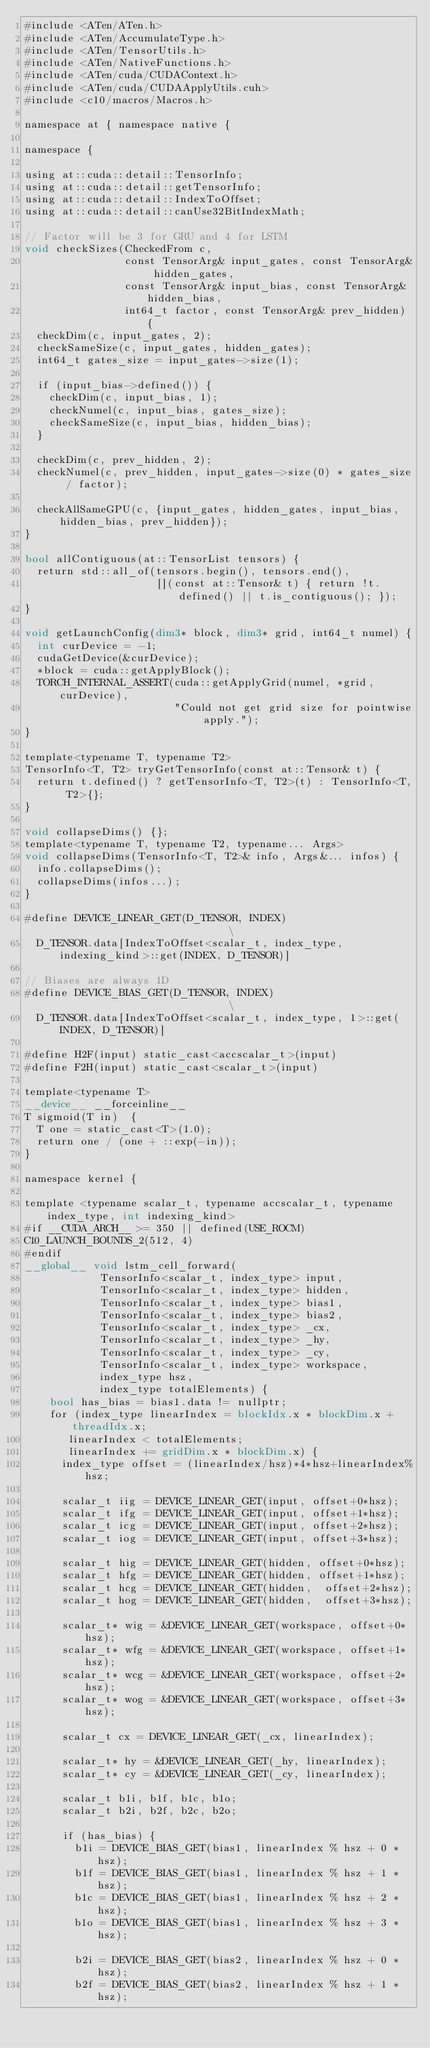<code> <loc_0><loc_0><loc_500><loc_500><_Cuda_>#include <ATen/ATen.h>
#include <ATen/AccumulateType.h>
#include <ATen/TensorUtils.h>
#include <ATen/NativeFunctions.h>
#include <ATen/cuda/CUDAContext.h>
#include <ATen/cuda/CUDAApplyUtils.cuh>
#include <c10/macros/Macros.h>

namespace at { namespace native {

namespace {

using at::cuda::detail::TensorInfo;
using at::cuda::detail::getTensorInfo;
using at::cuda::detail::IndexToOffset;
using at::cuda::detail::canUse32BitIndexMath;

// Factor will be 3 for GRU and 4 for LSTM
void checkSizes(CheckedFrom c,
                const TensorArg& input_gates, const TensorArg& hidden_gates,
                const TensorArg& input_bias, const TensorArg& hidden_bias,
                int64_t factor, const TensorArg& prev_hidden) {
  checkDim(c, input_gates, 2);
  checkSameSize(c, input_gates, hidden_gates);
  int64_t gates_size = input_gates->size(1);

  if (input_bias->defined()) {
    checkDim(c, input_bias, 1);
    checkNumel(c, input_bias, gates_size);
    checkSameSize(c, input_bias, hidden_bias);
  }

  checkDim(c, prev_hidden, 2);
  checkNumel(c, prev_hidden, input_gates->size(0) * gates_size / factor);

  checkAllSameGPU(c, {input_gates, hidden_gates, input_bias, hidden_bias, prev_hidden});
}

bool allContiguous(at::TensorList tensors) {
  return std::all_of(tensors.begin(), tensors.end(),
                     [](const at::Tensor& t) { return !t.defined() || t.is_contiguous(); });
}

void getLaunchConfig(dim3* block, dim3* grid, int64_t numel) {
  int curDevice = -1;
  cudaGetDevice(&curDevice);
  *block = cuda::getApplyBlock();
  TORCH_INTERNAL_ASSERT(cuda::getApplyGrid(numel, *grid, curDevice),
                        "Could not get grid size for pointwise apply.");
}

template<typename T, typename T2>
TensorInfo<T, T2> tryGetTensorInfo(const at::Tensor& t) {
  return t.defined() ? getTensorInfo<T, T2>(t) : TensorInfo<T, T2>{};
}

void collapseDims() {};
template<typename T, typename T2, typename... Args>
void collapseDims(TensorInfo<T, T2>& info, Args&... infos) {
  info.collapseDims();
  collapseDims(infos...);
}

#define DEVICE_LINEAR_GET(D_TENSOR, INDEX)                              \
  D_TENSOR.data[IndexToOffset<scalar_t, index_type, indexing_kind>::get(INDEX, D_TENSOR)]

// Biases are always 1D
#define DEVICE_BIAS_GET(D_TENSOR, INDEX)                              \
  D_TENSOR.data[IndexToOffset<scalar_t, index_type, 1>::get(INDEX, D_TENSOR)]

#define H2F(input) static_cast<accscalar_t>(input)
#define F2H(input) static_cast<scalar_t>(input)

template<typename T>
__device__ __forceinline__
T sigmoid(T in)  {
  T one = static_cast<T>(1.0);
  return one / (one + ::exp(-in));
}

namespace kernel {

template <typename scalar_t, typename accscalar_t, typename index_type, int indexing_kind>
#if __CUDA_ARCH__ >= 350 || defined(USE_ROCM)
C10_LAUNCH_BOUNDS_2(512, 4)
#endif
__global__ void lstm_cell_forward(
            TensorInfo<scalar_t, index_type> input,
            TensorInfo<scalar_t, index_type> hidden,
            TensorInfo<scalar_t, index_type> bias1,
            TensorInfo<scalar_t, index_type> bias2,
            TensorInfo<scalar_t, index_type> _cx,
            TensorInfo<scalar_t, index_type> _hy,
            TensorInfo<scalar_t, index_type> _cy,
            TensorInfo<scalar_t, index_type> workspace,
            index_type hsz,
            index_type totalElements) {
    bool has_bias = bias1.data != nullptr;
    for (index_type linearIndex = blockIdx.x * blockDim.x + threadIdx.x;
       linearIndex < totalElements;
       linearIndex += gridDim.x * blockDim.x) {
      index_type offset = (linearIndex/hsz)*4*hsz+linearIndex%hsz;

      scalar_t iig = DEVICE_LINEAR_GET(input, offset+0*hsz);
      scalar_t ifg = DEVICE_LINEAR_GET(input, offset+1*hsz);
      scalar_t icg = DEVICE_LINEAR_GET(input, offset+2*hsz);
      scalar_t iog = DEVICE_LINEAR_GET(input, offset+3*hsz);

      scalar_t hig = DEVICE_LINEAR_GET(hidden, offset+0*hsz);
      scalar_t hfg = DEVICE_LINEAR_GET(hidden, offset+1*hsz);
      scalar_t hcg = DEVICE_LINEAR_GET(hidden,  offset+2*hsz);
      scalar_t hog = DEVICE_LINEAR_GET(hidden,  offset+3*hsz);

      scalar_t* wig = &DEVICE_LINEAR_GET(workspace, offset+0*hsz);
      scalar_t* wfg = &DEVICE_LINEAR_GET(workspace, offset+1*hsz);
      scalar_t* wcg = &DEVICE_LINEAR_GET(workspace, offset+2*hsz);
      scalar_t* wog = &DEVICE_LINEAR_GET(workspace, offset+3*hsz);

      scalar_t cx = DEVICE_LINEAR_GET(_cx, linearIndex);

      scalar_t* hy = &DEVICE_LINEAR_GET(_hy, linearIndex);
      scalar_t* cy = &DEVICE_LINEAR_GET(_cy, linearIndex);

      scalar_t b1i, b1f, b1c, b1o;
      scalar_t b2i, b2f, b2c, b2o;

      if (has_bias) {
        b1i = DEVICE_BIAS_GET(bias1, linearIndex % hsz + 0 * hsz);
        b1f = DEVICE_BIAS_GET(bias1, linearIndex % hsz + 1 * hsz);
        b1c = DEVICE_BIAS_GET(bias1, linearIndex % hsz + 2 * hsz);
        b1o = DEVICE_BIAS_GET(bias1, linearIndex % hsz + 3 * hsz);

        b2i = DEVICE_BIAS_GET(bias2, linearIndex % hsz + 0 * hsz);
        b2f = DEVICE_BIAS_GET(bias2, linearIndex % hsz + 1 * hsz);</code> 